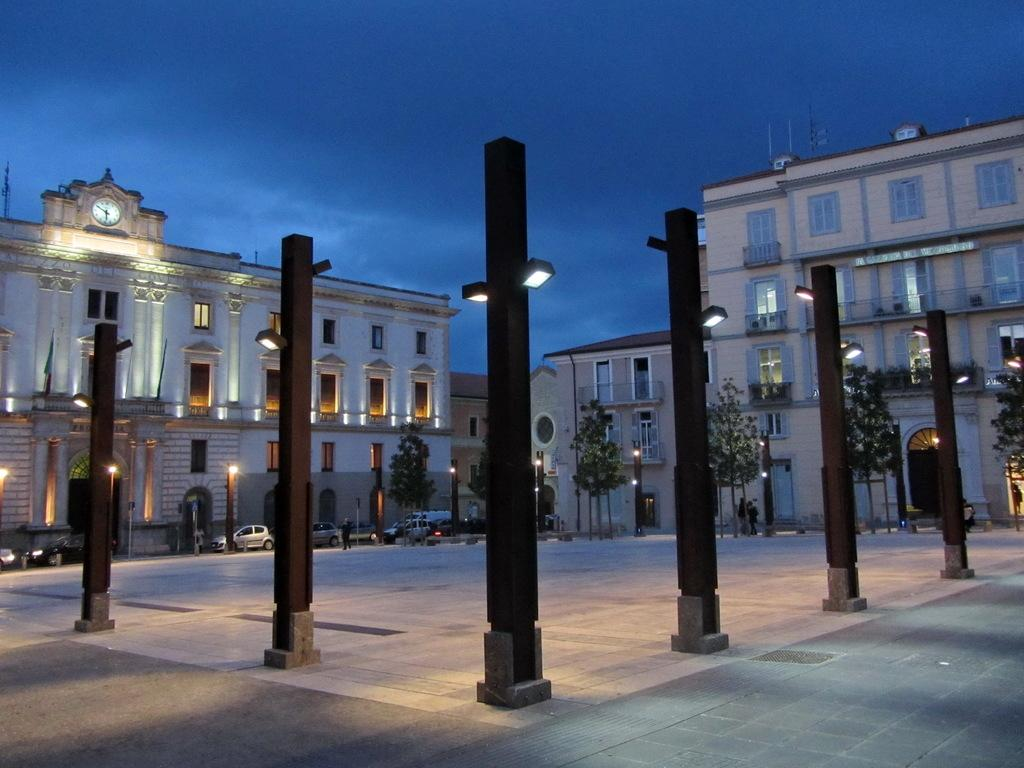What architectural features can be seen in the image? There are pillars in the image. What can be seen in the distance in the image? There are buildings, trees, lights, vehicles, and people in the background of the image. What type of juice is being served in the image? There is no juice present in the image. Is there a slope visible in the image? There is no slope visible in the image. 